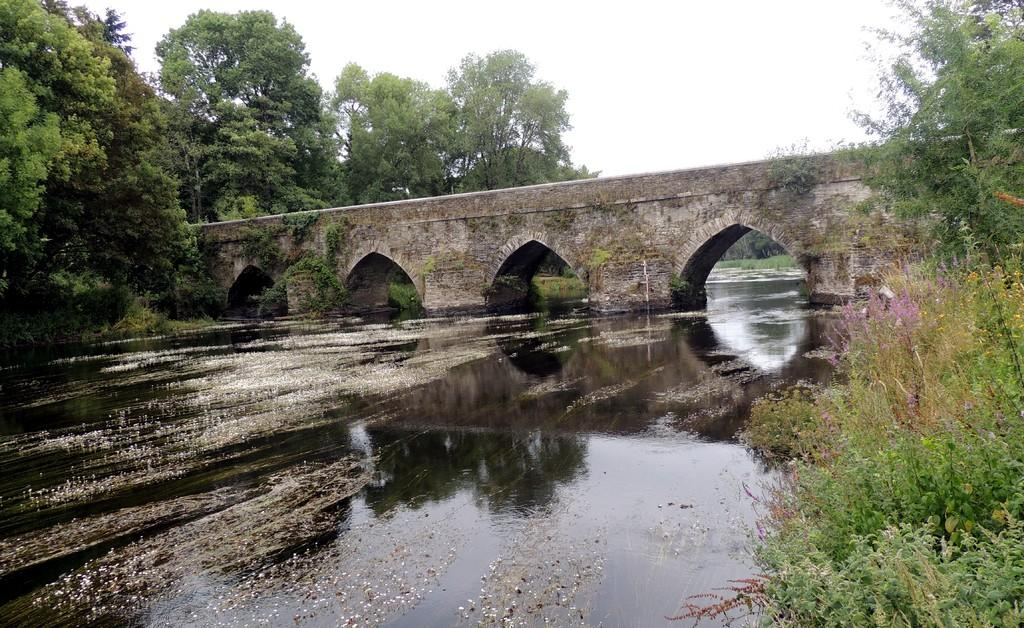What structure can be seen in the image? There is a bridge in the image. Where is the bridge located in relation to the water? The bridge is above the water. What type of vegetation is present in the image? There are plants and trees in the image. What can be seen in the background of the image? The sky is visible in the background of the image. What type of food is being served on the bridge in the image? There is no food present in the image, and the bridge is not serving any food. 